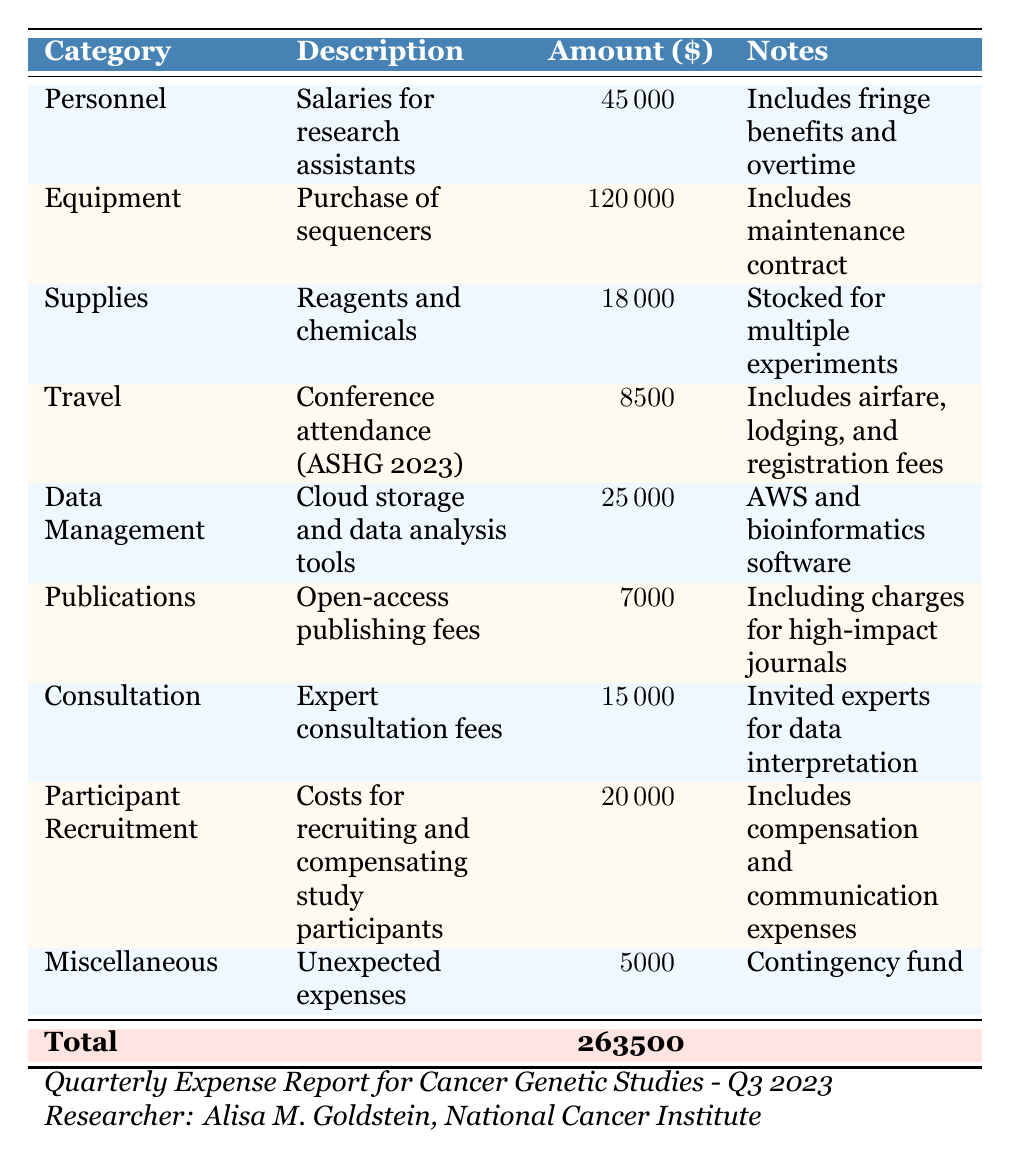What is the total amount spent on Personnel? The table lists the amount spent on Personnel under the "Amount" column in the relevant row. The listed amount for Personnel is $45,000.
Answer: 45000 What category has the highest expense? By reviewing the "Amount" column for each category, it is clear that Equipment has the highest expense, amounting to $120,000.
Answer: Equipment What is the total amount spent on Supplies and Data Management combined? The amount for Supplies is $18,000 and for Data Management, it is $25,000. Adding these two amounts (18,000 + 25,000) gives a total of $43,000.
Answer: 43000 Is the amount spent on Travel more than $10,000? The amount listed for Travel is $8,500, which is less than $10,000. Therefore, the answer is no.
Answer: No How much was spent on Publications, and what were the expenses for? The table shows that $7,000 was spent on Publications, which includes fees for open-access publishing in high-impact journals.
Answer: 7000 and open-access publishing fees What is the total expense across all categories? To find the total expense, we sum all the amounts in the "Amount" column: 45000 + 120000 + 18000 + 8500 + 25000 + 7000 + 15000 + 20000 + 5000 = $263,500.
Answer: 263500 How much did Alisa M. Goldstein’s studies spend on travel compared to participant recruitment? The table lists $8,500 for Travel and $20,000 for Participant Recruitment. Therefore, Participant Recruitment exceeded Travel by $20,000 - $8,500 = $11,500.
Answer: 11500 What percentage of the total expenses was spent on Equipment? The total expenses are $263,500, and the amount spent on Equipment is $120,000. To find the percentage: (120,000 / 263,500) * 100 ≈ 45.5%.
Answer: 45.5% Was any money allocated for unexpected expenses? The table indicates that there was a line for Miscellaneous where $5,000 was allocated for unexpected expenses (Contingency fund). Thus, yes, there were unexpected expenses.
Answer: Yes 